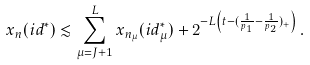Convert formula to latex. <formula><loc_0><loc_0><loc_500><loc_500>x _ { n } ( i d ^ { * } ) \lesssim \sum _ { \mu = J + 1 } ^ { L } x _ { n _ { \mu } } ( i d _ { \mu } ^ { * } ) + 2 ^ { - L \left ( t - ( \frac { 1 } { p _ { 1 } } - \frac { 1 } { p _ { 2 } } ) _ { + } \right ) } \, .</formula> 